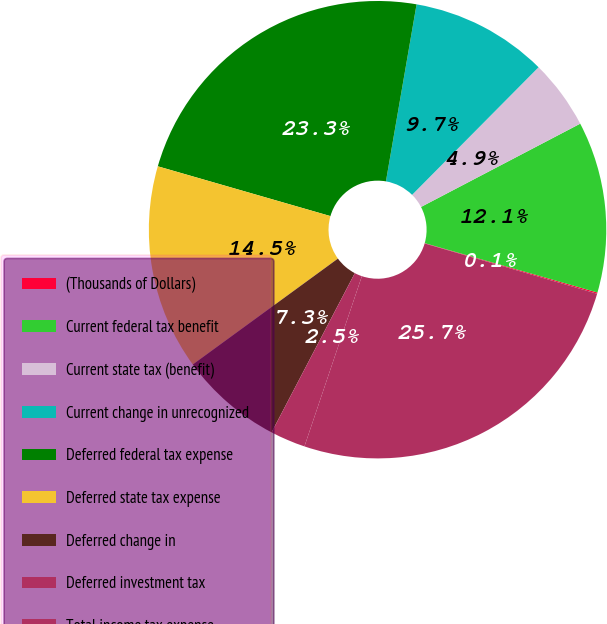Convert chart to OTSL. <chart><loc_0><loc_0><loc_500><loc_500><pie_chart><fcel>(Thousands of Dollars)<fcel>Current federal tax benefit<fcel>Current state tax (benefit)<fcel>Current change in unrecognized<fcel>Deferred federal tax expense<fcel>Deferred state tax expense<fcel>Deferred change in<fcel>Deferred investment tax<fcel>Total income tax expense<nl><fcel>0.09%<fcel>12.1%<fcel>4.9%<fcel>9.7%<fcel>23.26%<fcel>14.5%<fcel>7.3%<fcel>2.49%<fcel>25.66%<nl></chart> 